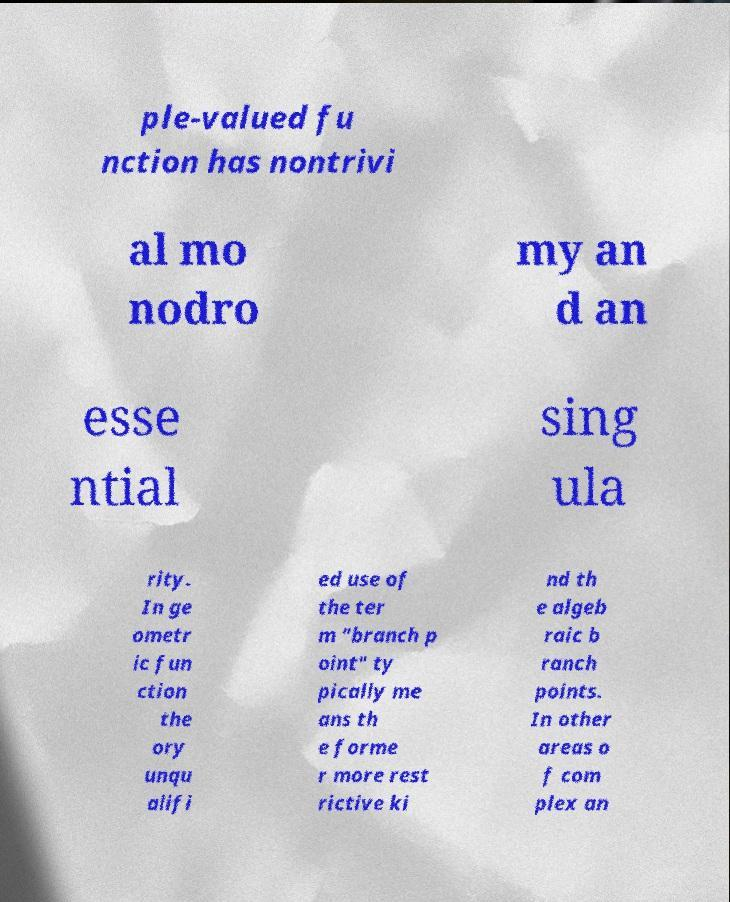Please read and relay the text visible in this image. What does it say? ple-valued fu nction has nontrivi al mo nodro my an d an esse ntial sing ula rity. In ge ometr ic fun ction the ory unqu alifi ed use of the ter m "branch p oint" ty pically me ans th e forme r more rest rictive ki nd th e algeb raic b ranch points. In other areas o f com plex an 